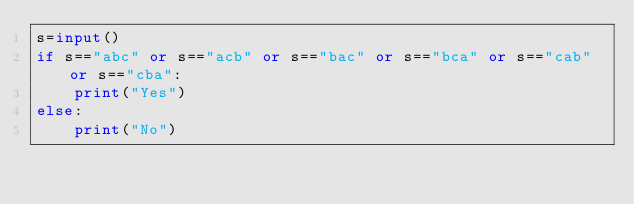Convert code to text. <code><loc_0><loc_0><loc_500><loc_500><_Python_>s=input()
if s=="abc" or s=="acb" or s=="bac" or s=="bca" or s=="cab" or s=="cba":
    print("Yes")
else:
    print("No")
</code> 